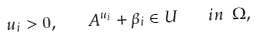Convert formula to latex. <formula><loc_0><loc_0><loc_500><loc_500>u _ { i } > 0 , \quad A ^ { u _ { i } } + \beta _ { i } \in U \quad i n \ \Omega ,</formula> 